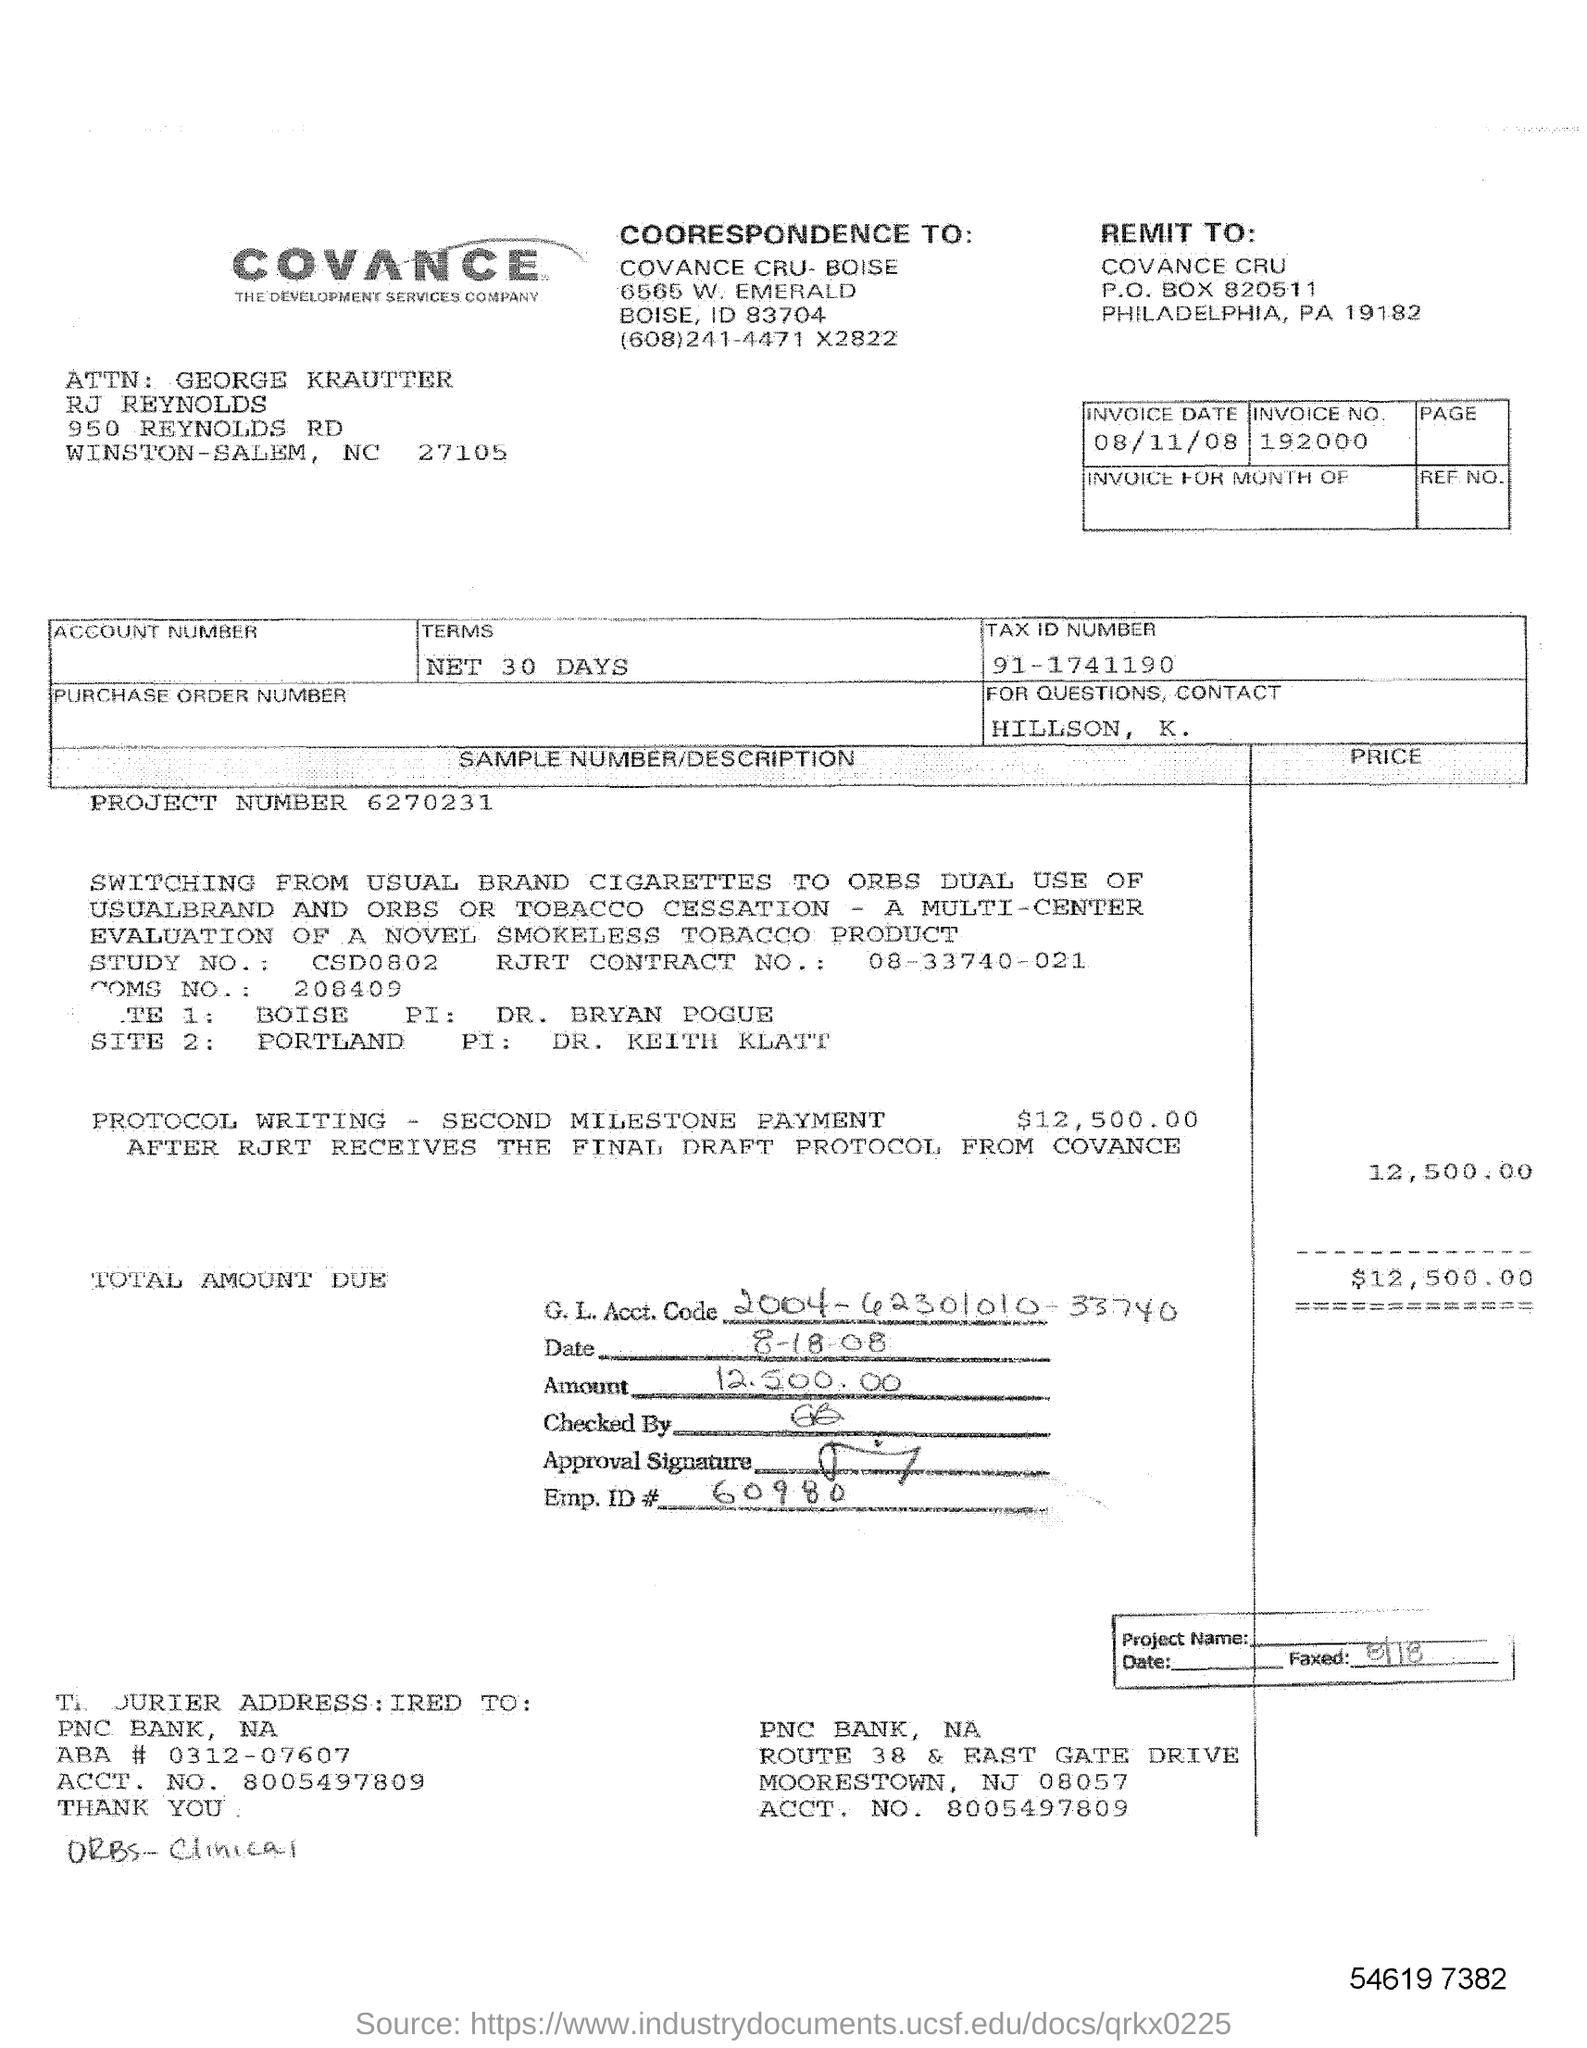What is the tax id number?
Your answer should be very brief. 91-1741190. What is the Project Number?
Offer a very short reply. 6270231. What is the Emp.ID?
Provide a succinct answer. 60980. What is the account number?
Your response must be concise. 8005497809. What is the RJRT Contract no.?
Make the answer very short. 08-33740-021. 